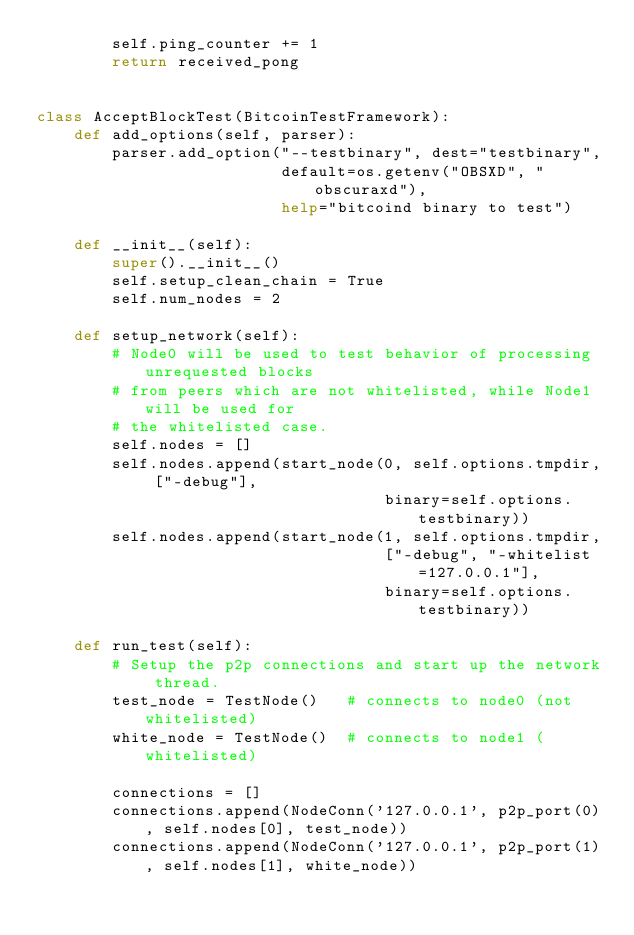Convert code to text. <code><loc_0><loc_0><loc_500><loc_500><_Python_>        self.ping_counter += 1
        return received_pong


class AcceptBlockTest(BitcoinTestFramework):
    def add_options(self, parser):
        parser.add_option("--testbinary", dest="testbinary",
                          default=os.getenv("OBSXD", "obscuraxd"),
                          help="bitcoind binary to test")

    def __init__(self):
        super().__init__()
        self.setup_clean_chain = True
        self.num_nodes = 2

    def setup_network(self):
        # Node0 will be used to test behavior of processing unrequested blocks
        # from peers which are not whitelisted, while Node1 will be used for
        # the whitelisted case.
        self.nodes = []
        self.nodes.append(start_node(0, self.options.tmpdir, ["-debug"],
                                     binary=self.options.testbinary))
        self.nodes.append(start_node(1, self.options.tmpdir,
                                     ["-debug", "-whitelist=127.0.0.1"],
                                     binary=self.options.testbinary))

    def run_test(self):
        # Setup the p2p connections and start up the network thread.
        test_node = TestNode()   # connects to node0 (not whitelisted)
        white_node = TestNode()  # connects to node1 (whitelisted)

        connections = []
        connections.append(NodeConn('127.0.0.1', p2p_port(0), self.nodes[0], test_node))
        connections.append(NodeConn('127.0.0.1', p2p_port(1), self.nodes[1], white_node))</code> 